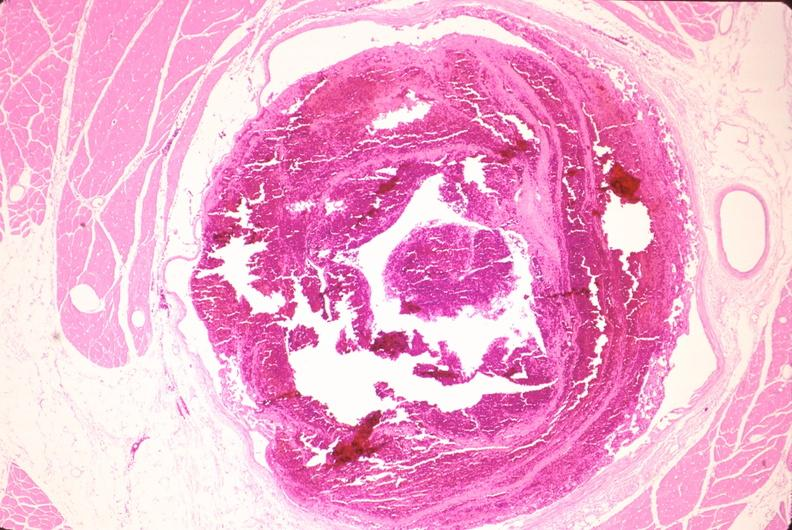does this image show leg veins, thrombus?
Answer the question using a single word or phrase. Yes 